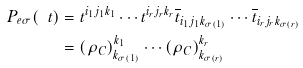Convert formula to latex. <formula><loc_0><loc_0><loc_500><loc_500>P _ { e \sigma } ( \ t ) & = t ^ { i _ { 1 } j _ { 1 } k _ { 1 } } \cdots t ^ { i _ { r } j _ { r } k _ { r } } \overline { t } _ { i _ { 1 } j _ { 1 } k _ { \sigma ( 1 ) } } \cdots \overline { t } _ { i _ { r } j _ { r } k _ { \sigma ( r ) } } \\ & = ( \rho _ { C } ) ^ { k _ { 1 } } _ { k _ { \sigma ( 1 ) } } \cdots ( \rho _ { C } ) ^ { k _ { r } } _ { k _ { \sigma ( r ) } }</formula> 